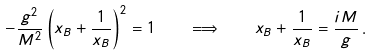Convert formula to latex. <formula><loc_0><loc_0><loc_500><loc_500>- \frac { g ^ { 2 } } { M ^ { 2 } } \left ( x _ { B } + \frac { 1 } { x _ { B } } \right ) ^ { 2 } = 1 \quad \Longrightarrow \quad x _ { B } + \frac { 1 } { x _ { B } } = \frac { i M } { g } \, .</formula> 